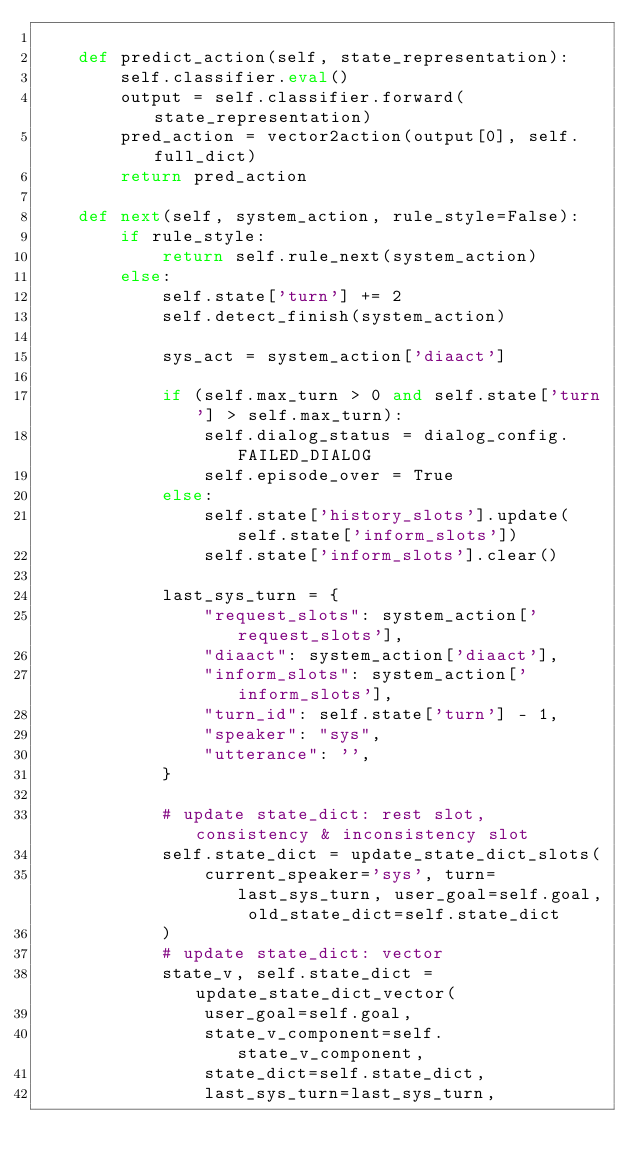<code> <loc_0><loc_0><loc_500><loc_500><_Python_>
    def predict_action(self, state_representation):
        self.classifier.eval()
        output = self.classifier.forward(state_representation)
        pred_action = vector2action(output[0], self.full_dict)
        return pred_action

    def next(self, system_action, rule_style=False):
        if rule_style:
            return self.rule_next(system_action)
        else:
            self.state['turn'] += 2
            self.detect_finish(system_action)

            sys_act = system_action['diaact']

            if (self.max_turn > 0 and self.state['turn'] > self.max_turn):
                self.dialog_status = dialog_config.FAILED_DIALOG
                self.episode_over = True
            else:
                self.state['history_slots'].update(self.state['inform_slots'])
                self.state['inform_slots'].clear()

            last_sys_turn = {
                "request_slots": system_action['request_slots'],
                "diaact": system_action['diaact'],
                "inform_slots": system_action['inform_slots'],
                "turn_id": self.state['turn'] - 1,
                "speaker": "sys",
                "utterance": '',
            }

            # update state_dict: rest slot, consistency & inconsistency slot
            self.state_dict = update_state_dict_slots(
                current_speaker='sys', turn=last_sys_turn, user_goal=self.goal, old_state_dict=self.state_dict
            )
            # update state_dict: vector
            state_v, self.state_dict = update_state_dict_vector(
                user_goal=self.goal,
                state_v_component=self.state_v_component,
                state_dict=self.state_dict,
                last_sys_turn=last_sys_turn,</code> 